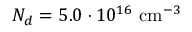Convert formula to latex. <formula><loc_0><loc_0><loc_500><loc_500>N _ { d } = 5 . 0 \cdot 1 0 ^ { 1 6 } { c m ^ { - 3 } }</formula> 